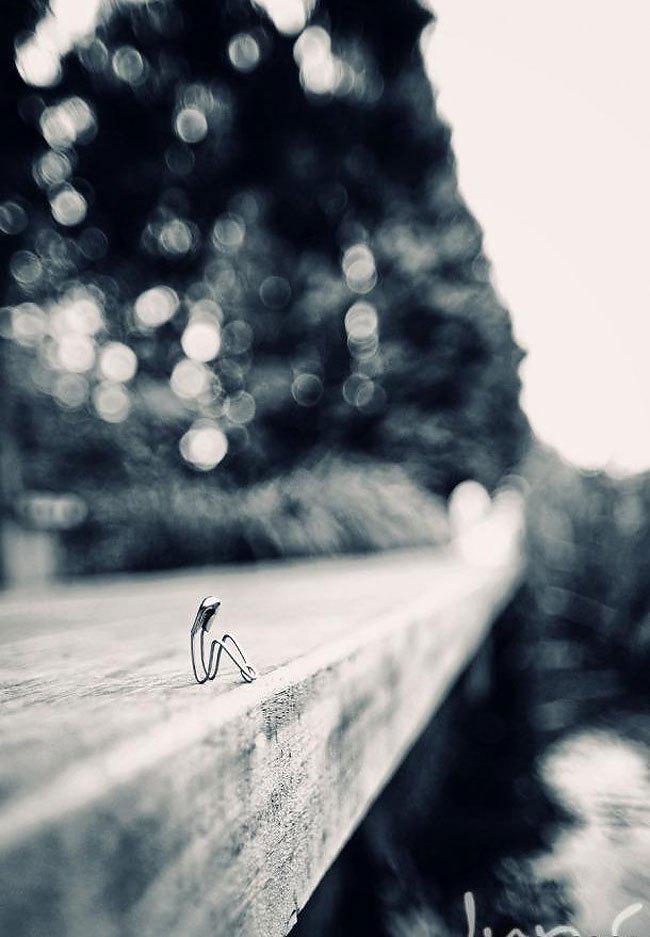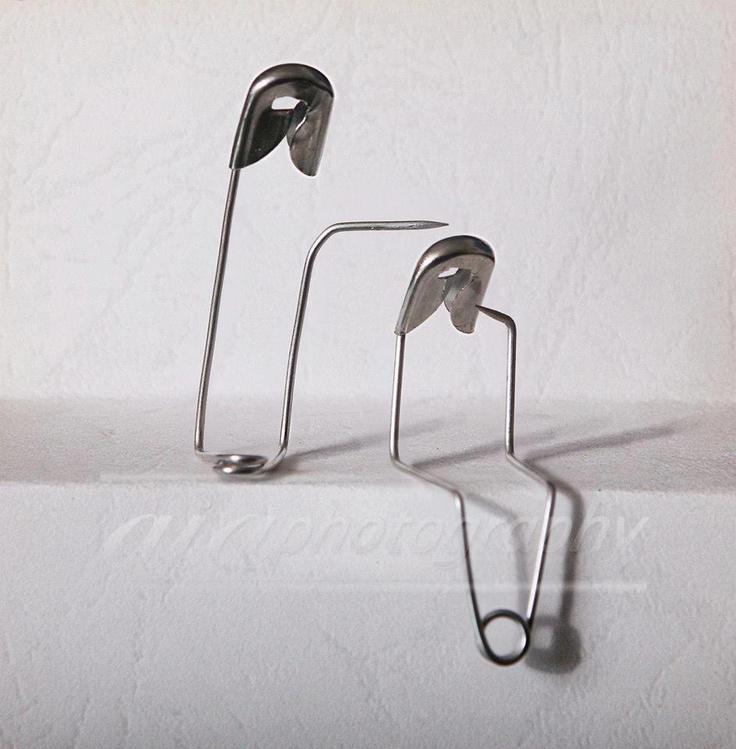The first image is the image on the left, the second image is the image on the right. Considering the images on both sides, is "One safety pin is open and bent with it' sharp point above another safety pin." valid? Answer yes or no. Yes. The first image is the image on the left, the second image is the image on the right. Assess this claim about the two images: "a bobby pin is bent and sitting on a tiny chair". Correct or not? Answer yes or no. No. 